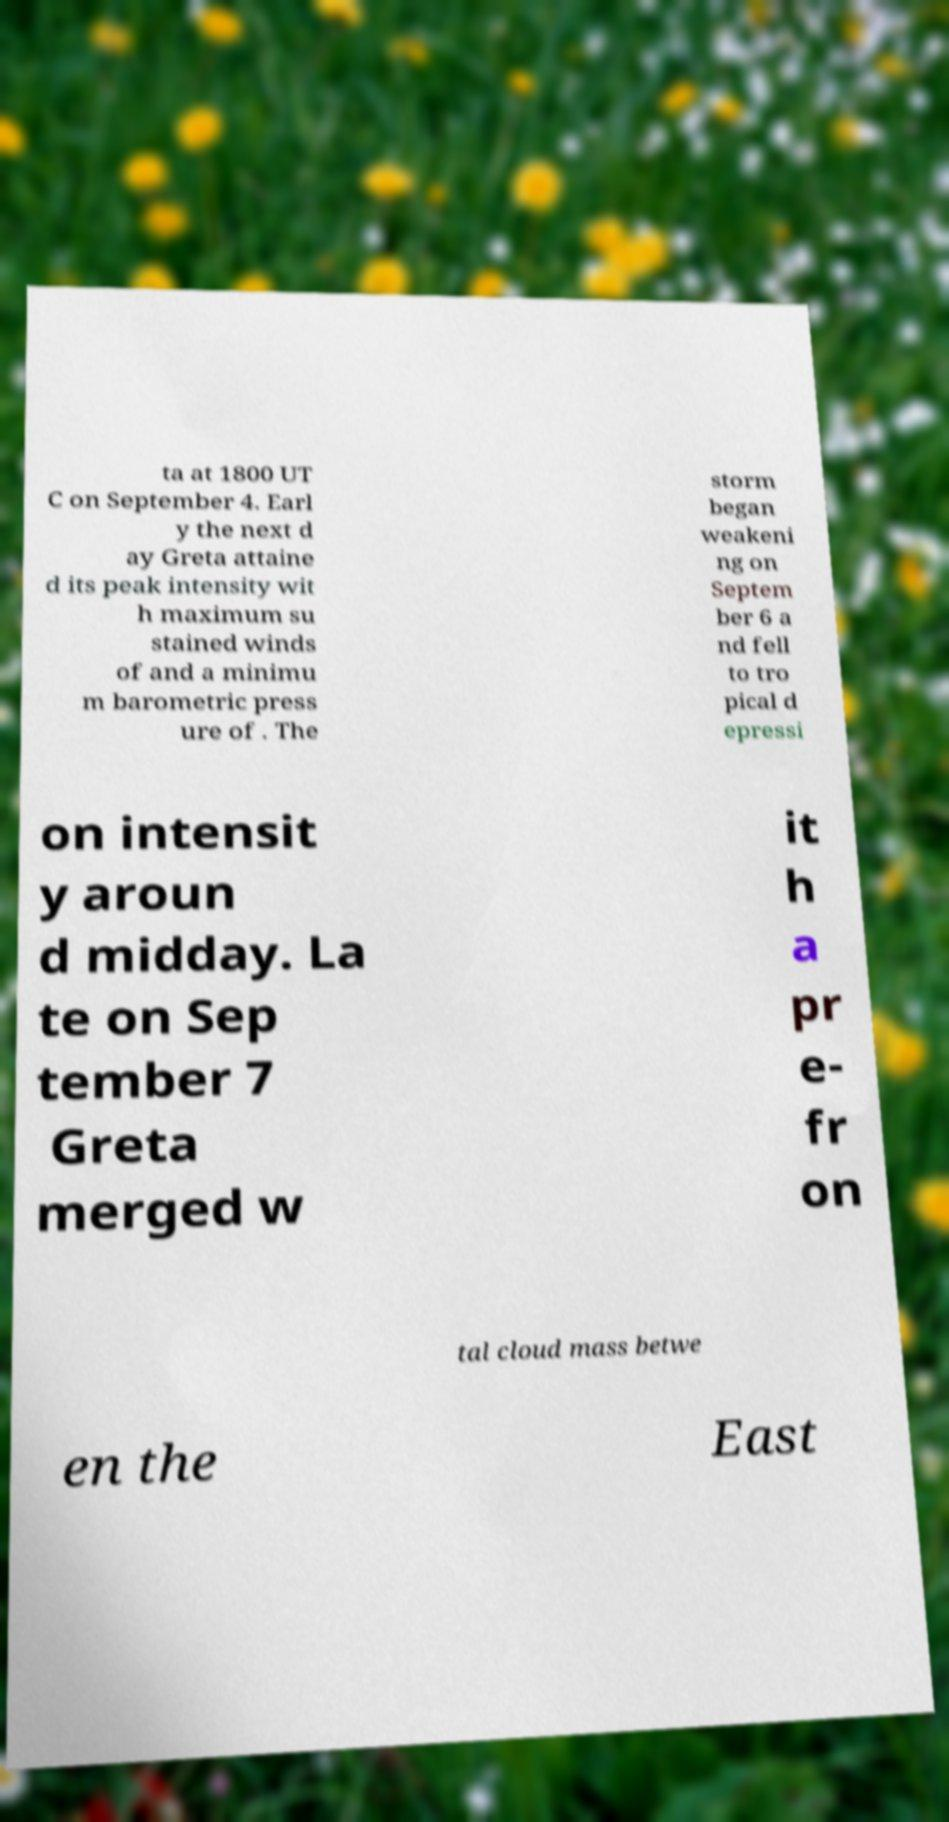There's text embedded in this image that I need extracted. Can you transcribe it verbatim? ta at 1800 UT C on September 4. Earl y the next d ay Greta attaine d its peak intensity wit h maximum su stained winds of and a minimu m barometric press ure of . The storm began weakeni ng on Septem ber 6 a nd fell to tro pical d epressi on intensit y aroun d midday. La te on Sep tember 7 Greta merged w it h a pr e- fr on tal cloud mass betwe en the East 